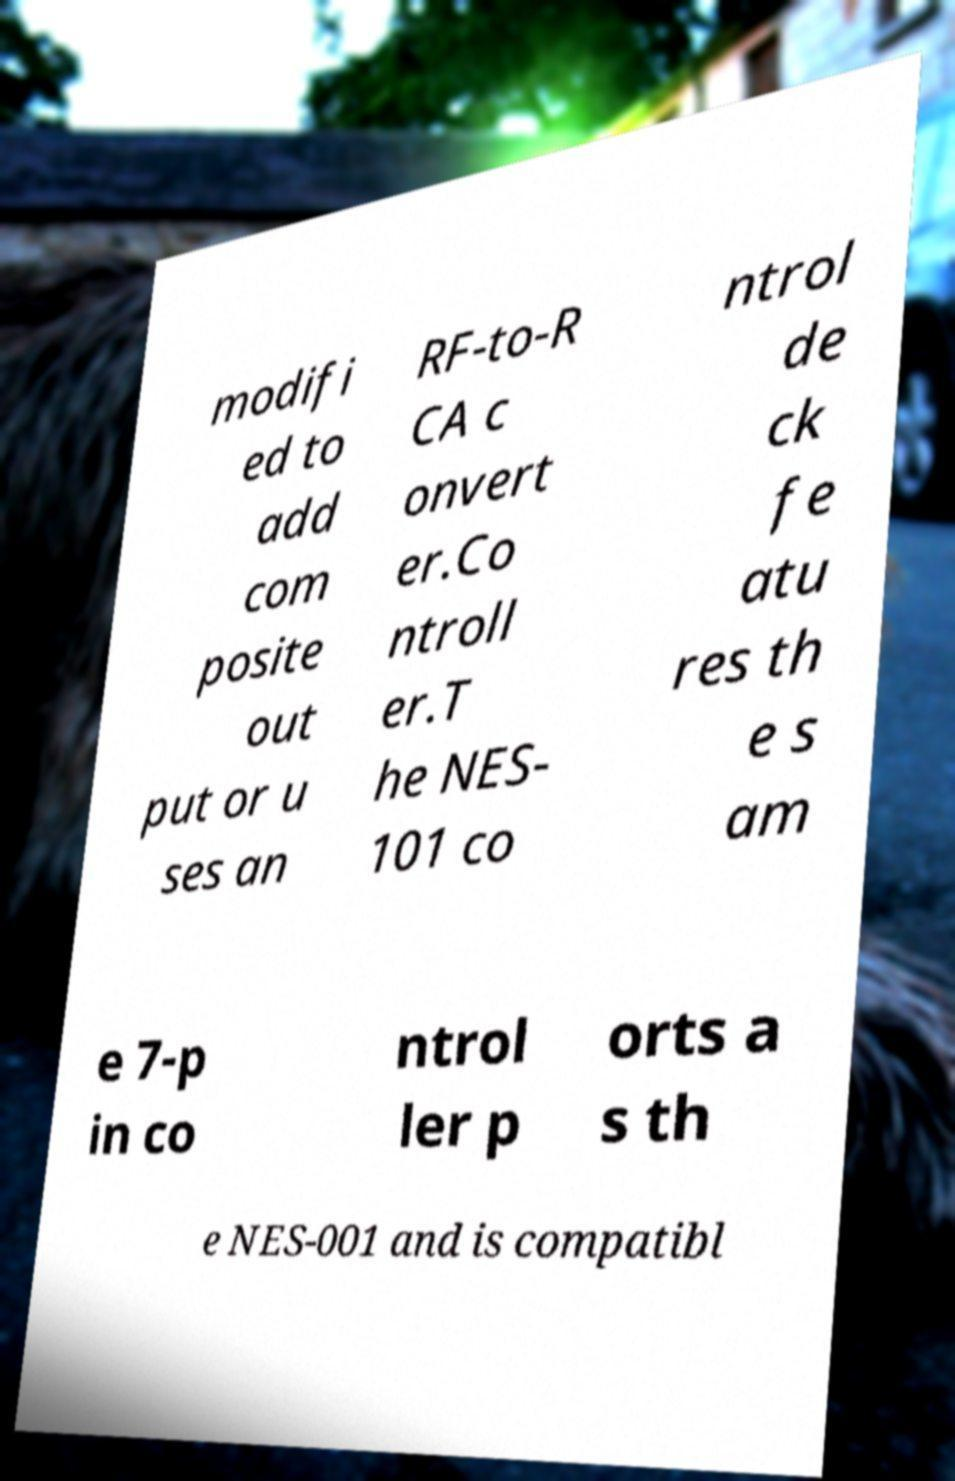There's text embedded in this image that I need extracted. Can you transcribe it verbatim? modifi ed to add com posite out put or u ses an RF-to-R CA c onvert er.Co ntroll er.T he NES- 101 co ntrol de ck fe atu res th e s am e 7-p in co ntrol ler p orts a s th e NES-001 and is compatibl 